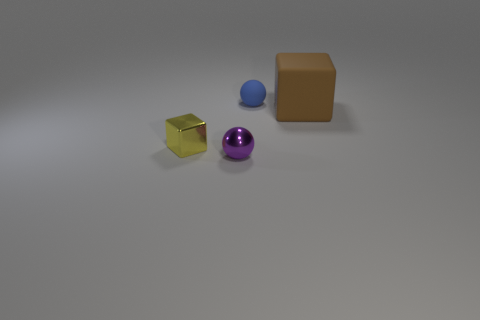Add 4 matte objects. How many objects exist? 8 Add 1 blue spheres. How many blue spheres exist? 2 Subtract 0 green cylinders. How many objects are left? 4 Subtract all balls. Subtract all large brown rubber cubes. How many objects are left? 1 Add 2 small metallic blocks. How many small metallic blocks are left? 3 